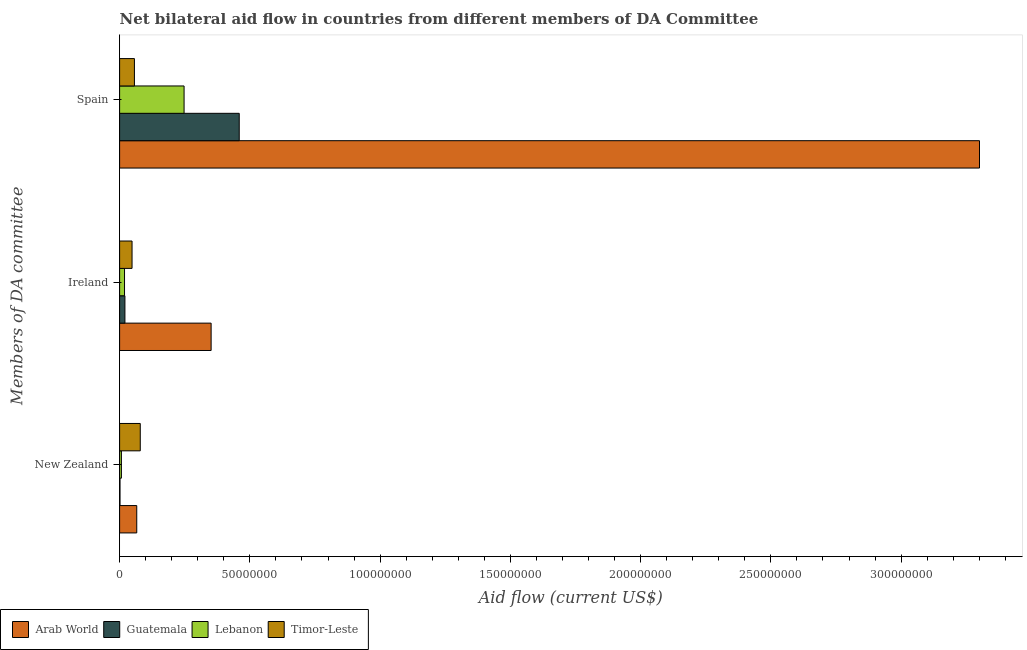How many different coloured bars are there?
Your response must be concise. 4. Are the number of bars per tick equal to the number of legend labels?
Keep it short and to the point. Yes. Are the number of bars on each tick of the Y-axis equal?
Make the answer very short. Yes. How many bars are there on the 3rd tick from the top?
Provide a succinct answer. 4. What is the label of the 1st group of bars from the top?
Ensure brevity in your answer.  Spain. What is the amount of aid provided by ireland in Timor-Leste?
Your answer should be compact. 4.78e+06. Across all countries, what is the maximum amount of aid provided by spain?
Your answer should be compact. 3.30e+08. Across all countries, what is the minimum amount of aid provided by new zealand?
Give a very brief answer. 1.50e+05. In which country was the amount of aid provided by spain maximum?
Make the answer very short. Arab World. In which country was the amount of aid provided by new zealand minimum?
Provide a succinct answer. Guatemala. What is the total amount of aid provided by new zealand in the graph?
Offer a terse response. 1.54e+07. What is the difference between the amount of aid provided by new zealand in Guatemala and that in Lebanon?
Your response must be concise. -5.40e+05. What is the difference between the amount of aid provided by ireland in Arab World and the amount of aid provided by new zealand in Lebanon?
Keep it short and to the point. 3.44e+07. What is the average amount of aid provided by spain per country?
Provide a succinct answer. 1.02e+08. What is the difference between the amount of aid provided by spain and amount of aid provided by new zealand in Lebanon?
Make the answer very short. 2.41e+07. What is the ratio of the amount of aid provided by ireland in Lebanon to that in Timor-Leste?
Provide a short and direct response. 0.4. Is the difference between the amount of aid provided by spain in Lebanon and Timor-Leste greater than the difference between the amount of aid provided by new zealand in Lebanon and Timor-Leste?
Your answer should be very brief. Yes. What is the difference between the highest and the second highest amount of aid provided by new zealand?
Provide a short and direct response. 1.35e+06. What is the difference between the highest and the lowest amount of aid provided by spain?
Your answer should be compact. 3.24e+08. What does the 3rd bar from the top in Ireland represents?
Provide a succinct answer. Guatemala. What does the 2nd bar from the bottom in Ireland represents?
Keep it short and to the point. Guatemala. How many bars are there?
Ensure brevity in your answer.  12. How many countries are there in the graph?
Make the answer very short. 4. What is the difference between two consecutive major ticks on the X-axis?
Your answer should be compact. 5.00e+07. Does the graph contain grids?
Your answer should be very brief. No. How many legend labels are there?
Keep it short and to the point. 4. How are the legend labels stacked?
Offer a terse response. Horizontal. What is the title of the graph?
Your answer should be very brief. Net bilateral aid flow in countries from different members of DA Committee. What is the label or title of the X-axis?
Offer a terse response. Aid flow (current US$). What is the label or title of the Y-axis?
Give a very brief answer. Members of DA committee. What is the Aid flow (current US$) in Arab World in New Zealand?
Give a very brief answer. 6.58e+06. What is the Aid flow (current US$) of Lebanon in New Zealand?
Offer a very short reply. 6.90e+05. What is the Aid flow (current US$) of Timor-Leste in New Zealand?
Provide a succinct answer. 7.93e+06. What is the Aid flow (current US$) in Arab World in Ireland?
Provide a succinct answer. 3.51e+07. What is the Aid flow (current US$) in Guatemala in Ireland?
Offer a terse response. 2.04e+06. What is the Aid flow (current US$) in Lebanon in Ireland?
Your response must be concise. 1.89e+06. What is the Aid flow (current US$) of Timor-Leste in Ireland?
Ensure brevity in your answer.  4.78e+06. What is the Aid flow (current US$) of Arab World in Spain?
Your response must be concise. 3.30e+08. What is the Aid flow (current US$) of Guatemala in Spain?
Offer a terse response. 4.59e+07. What is the Aid flow (current US$) of Lebanon in Spain?
Keep it short and to the point. 2.48e+07. What is the Aid flow (current US$) in Timor-Leste in Spain?
Keep it short and to the point. 5.69e+06. Across all Members of DA committee, what is the maximum Aid flow (current US$) in Arab World?
Make the answer very short. 3.30e+08. Across all Members of DA committee, what is the maximum Aid flow (current US$) in Guatemala?
Provide a succinct answer. 4.59e+07. Across all Members of DA committee, what is the maximum Aid flow (current US$) in Lebanon?
Provide a succinct answer. 2.48e+07. Across all Members of DA committee, what is the maximum Aid flow (current US$) of Timor-Leste?
Give a very brief answer. 7.93e+06. Across all Members of DA committee, what is the minimum Aid flow (current US$) of Arab World?
Provide a succinct answer. 6.58e+06. Across all Members of DA committee, what is the minimum Aid flow (current US$) of Lebanon?
Offer a very short reply. 6.90e+05. Across all Members of DA committee, what is the minimum Aid flow (current US$) of Timor-Leste?
Your answer should be compact. 4.78e+06. What is the total Aid flow (current US$) of Arab World in the graph?
Offer a very short reply. 3.72e+08. What is the total Aid flow (current US$) in Guatemala in the graph?
Make the answer very short. 4.81e+07. What is the total Aid flow (current US$) of Lebanon in the graph?
Your response must be concise. 2.73e+07. What is the total Aid flow (current US$) of Timor-Leste in the graph?
Your answer should be compact. 1.84e+07. What is the difference between the Aid flow (current US$) of Arab World in New Zealand and that in Ireland?
Keep it short and to the point. -2.86e+07. What is the difference between the Aid flow (current US$) in Guatemala in New Zealand and that in Ireland?
Provide a short and direct response. -1.89e+06. What is the difference between the Aid flow (current US$) of Lebanon in New Zealand and that in Ireland?
Provide a succinct answer. -1.20e+06. What is the difference between the Aid flow (current US$) of Timor-Leste in New Zealand and that in Ireland?
Your response must be concise. 3.15e+06. What is the difference between the Aid flow (current US$) in Arab World in New Zealand and that in Spain?
Your response must be concise. -3.24e+08. What is the difference between the Aid flow (current US$) in Guatemala in New Zealand and that in Spain?
Your answer should be very brief. -4.58e+07. What is the difference between the Aid flow (current US$) of Lebanon in New Zealand and that in Spain?
Ensure brevity in your answer.  -2.41e+07. What is the difference between the Aid flow (current US$) of Timor-Leste in New Zealand and that in Spain?
Ensure brevity in your answer.  2.24e+06. What is the difference between the Aid flow (current US$) of Arab World in Ireland and that in Spain?
Keep it short and to the point. -2.95e+08. What is the difference between the Aid flow (current US$) of Guatemala in Ireland and that in Spain?
Make the answer very short. -4.39e+07. What is the difference between the Aid flow (current US$) of Lebanon in Ireland and that in Spain?
Provide a succinct answer. -2.29e+07. What is the difference between the Aid flow (current US$) in Timor-Leste in Ireland and that in Spain?
Offer a very short reply. -9.10e+05. What is the difference between the Aid flow (current US$) of Arab World in New Zealand and the Aid flow (current US$) of Guatemala in Ireland?
Offer a terse response. 4.54e+06. What is the difference between the Aid flow (current US$) of Arab World in New Zealand and the Aid flow (current US$) of Lebanon in Ireland?
Keep it short and to the point. 4.69e+06. What is the difference between the Aid flow (current US$) in Arab World in New Zealand and the Aid flow (current US$) in Timor-Leste in Ireland?
Your answer should be compact. 1.80e+06. What is the difference between the Aid flow (current US$) in Guatemala in New Zealand and the Aid flow (current US$) in Lebanon in Ireland?
Keep it short and to the point. -1.74e+06. What is the difference between the Aid flow (current US$) of Guatemala in New Zealand and the Aid flow (current US$) of Timor-Leste in Ireland?
Offer a terse response. -4.63e+06. What is the difference between the Aid flow (current US$) of Lebanon in New Zealand and the Aid flow (current US$) of Timor-Leste in Ireland?
Offer a very short reply. -4.09e+06. What is the difference between the Aid flow (current US$) of Arab World in New Zealand and the Aid flow (current US$) of Guatemala in Spain?
Offer a terse response. -3.93e+07. What is the difference between the Aid flow (current US$) of Arab World in New Zealand and the Aid flow (current US$) of Lebanon in Spain?
Keep it short and to the point. -1.82e+07. What is the difference between the Aid flow (current US$) in Arab World in New Zealand and the Aid flow (current US$) in Timor-Leste in Spain?
Provide a succinct answer. 8.90e+05. What is the difference between the Aid flow (current US$) of Guatemala in New Zealand and the Aid flow (current US$) of Lebanon in Spain?
Offer a very short reply. -2.46e+07. What is the difference between the Aid flow (current US$) in Guatemala in New Zealand and the Aid flow (current US$) in Timor-Leste in Spain?
Provide a short and direct response. -5.54e+06. What is the difference between the Aid flow (current US$) in Lebanon in New Zealand and the Aid flow (current US$) in Timor-Leste in Spain?
Ensure brevity in your answer.  -5.00e+06. What is the difference between the Aid flow (current US$) of Arab World in Ireland and the Aid flow (current US$) of Guatemala in Spain?
Your answer should be very brief. -1.08e+07. What is the difference between the Aid flow (current US$) in Arab World in Ireland and the Aid flow (current US$) in Lebanon in Spain?
Provide a short and direct response. 1.04e+07. What is the difference between the Aid flow (current US$) in Arab World in Ireland and the Aid flow (current US$) in Timor-Leste in Spain?
Provide a short and direct response. 2.94e+07. What is the difference between the Aid flow (current US$) of Guatemala in Ireland and the Aid flow (current US$) of Lebanon in Spain?
Your answer should be very brief. -2.27e+07. What is the difference between the Aid flow (current US$) in Guatemala in Ireland and the Aid flow (current US$) in Timor-Leste in Spain?
Provide a short and direct response. -3.65e+06. What is the difference between the Aid flow (current US$) of Lebanon in Ireland and the Aid flow (current US$) of Timor-Leste in Spain?
Provide a short and direct response. -3.80e+06. What is the average Aid flow (current US$) in Arab World per Members of DA committee?
Your answer should be very brief. 1.24e+08. What is the average Aid flow (current US$) of Guatemala per Members of DA committee?
Provide a succinct answer. 1.60e+07. What is the average Aid flow (current US$) of Lebanon per Members of DA committee?
Provide a succinct answer. 9.11e+06. What is the average Aid flow (current US$) of Timor-Leste per Members of DA committee?
Make the answer very short. 6.13e+06. What is the difference between the Aid flow (current US$) in Arab World and Aid flow (current US$) in Guatemala in New Zealand?
Your response must be concise. 6.43e+06. What is the difference between the Aid flow (current US$) of Arab World and Aid flow (current US$) of Lebanon in New Zealand?
Ensure brevity in your answer.  5.89e+06. What is the difference between the Aid flow (current US$) of Arab World and Aid flow (current US$) of Timor-Leste in New Zealand?
Make the answer very short. -1.35e+06. What is the difference between the Aid flow (current US$) of Guatemala and Aid flow (current US$) of Lebanon in New Zealand?
Give a very brief answer. -5.40e+05. What is the difference between the Aid flow (current US$) in Guatemala and Aid flow (current US$) in Timor-Leste in New Zealand?
Keep it short and to the point. -7.78e+06. What is the difference between the Aid flow (current US$) of Lebanon and Aid flow (current US$) of Timor-Leste in New Zealand?
Ensure brevity in your answer.  -7.24e+06. What is the difference between the Aid flow (current US$) in Arab World and Aid flow (current US$) in Guatemala in Ireland?
Offer a terse response. 3.31e+07. What is the difference between the Aid flow (current US$) of Arab World and Aid flow (current US$) of Lebanon in Ireland?
Ensure brevity in your answer.  3.32e+07. What is the difference between the Aid flow (current US$) in Arab World and Aid flow (current US$) in Timor-Leste in Ireland?
Give a very brief answer. 3.04e+07. What is the difference between the Aid flow (current US$) of Guatemala and Aid flow (current US$) of Lebanon in Ireland?
Ensure brevity in your answer.  1.50e+05. What is the difference between the Aid flow (current US$) of Guatemala and Aid flow (current US$) of Timor-Leste in Ireland?
Give a very brief answer. -2.74e+06. What is the difference between the Aid flow (current US$) in Lebanon and Aid flow (current US$) in Timor-Leste in Ireland?
Your answer should be very brief. -2.89e+06. What is the difference between the Aid flow (current US$) of Arab World and Aid flow (current US$) of Guatemala in Spain?
Your response must be concise. 2.84e+08. What is the difference between the Aid flow (current US$) in Arab World and Aid flow (current US$) in Lebanon in Spain?
Your answer should be very brief. 3.05e+08. What is the difference between the Aid flow (current US$) of Arab World and Aid flow (current US$) of Timor-Leste in Spain?
Your response must be concise. 3.24e+08. What is the difference between the Aid flow (current US$) in Guatemala and Aid flow (current US$) in Lebanon in Spain?
Keep it short and to the point. 2.12e+07. What is the difference between the Aid flow (current US$) in Guatemala and Aid flow (current US$) in Timor-Leste in Spain?
Keep it short and to the point. 4.02e+07. What is the difference between the Aid flow (current US$) in Lebanon and Aid flow (current US$) in Timor-Leste in Spain?
Give a very brief answer. 1.91e+07. What is the ratio of the Aid flow (current US$) of Arab World in New Zealand to that in Ireland?
Your answer should be very brief. 0.19. What is the ratio of the Aid flow (current US$) of Guatemala in New Zealand to that in Ireland?
Provide a short and direct response. 0.07. What is the ratio of the Aid flow (current US$) in Lebanon in New Zealand to that in Ireland?
Provide a succinct answer. 0.37. What is the ratio of the Aid flow (current US$) in Timor-Leste in New Zealand to that in Ireland?
Ensure brevity in your answer.  1.66. What is the ratio of the Aid flow (current US$) of Arab World in New Zealand to that in Spain?
Offer a very short reply. 0.02. What is the ratio of the Aid flow (current US$) in Guatemala in New Zealand to that in Spain?
Ensure brevity in your answer.  0. What is the ratio of the Aid flow (current US$) of Lebanon in New Zealand to that in Spain?
Give a very brief answer. 0.03. What is the ratio of the Aid flow (current US$) in Timor-Leste in New Zealand to that in Spain?
Give a very brief answer. 1.39. What is the ratio of the Aid flow (current US$) in Arab World in Ireland to that in Spain?
Your response must be concise. 0.11. What is the ratio of the Aid flow (current US$) in Guatemala in Ireland to that in Spain?
Your answer should be compact. 0.04. What is the ratio of the Aid flow (current US$) in Lebanon in Ireland to that in Spain?
Offer a terse response. 0.08. What is the ratio of the Aid flow (current US$) of Timor-Leste in Ireland to that in Spain?
Offer a terse response. 0.84. What is the difference between the highest and the second highest Aid flow (current US$) in Arab World?
Keep it short and to the point. 2.95e+08. What is the difference between the highest and the second highest Aid flow (current US$) of Guatemala?
Keep it short and to the point. 4.39e+07. What is the difference between the highest and the second highest Aid flow (current US$) of Lebanon?
Offer a very short reply. 2.29e+07. What is the difference between the highest and the second highest Aid flow (current US$) of Timor-Leste?
Your answer should be very brief. 2.24e+06. What is the difference between the highest and the lowest Aid flow (current US$) in Arab World?
Provide a succinct answer. 3.24e+08. What is the difference between the highest and the lowest Aid flow (current US$) of Guatemala?
Ensure brevity in your answer.  4.58e+07. What is the difference between the highest and the lowest Aid flow (current US$) in Lebanon?
Give a very brief answer. 2.41e+07. What is the difference between the highest and the lowest Aid flow (current US$) in Timor-Leste?
Provide a succinct answer. 3.15e+06. 